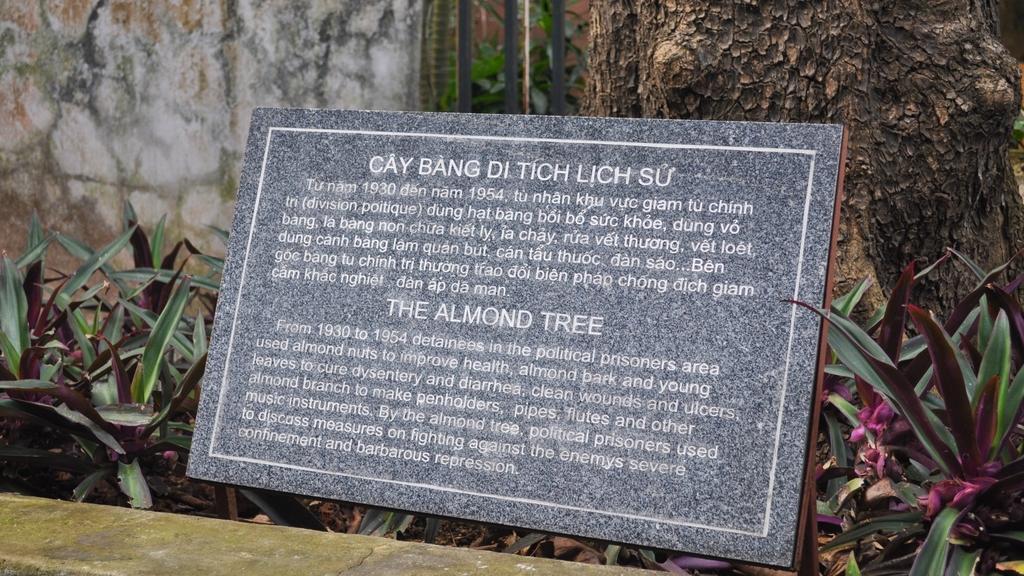How would you summarize this image in a sentence or two? There is a commemorative plaque on which, there are tests, near plants and tree. In front of them, there is wall. In the background, there is wall. 